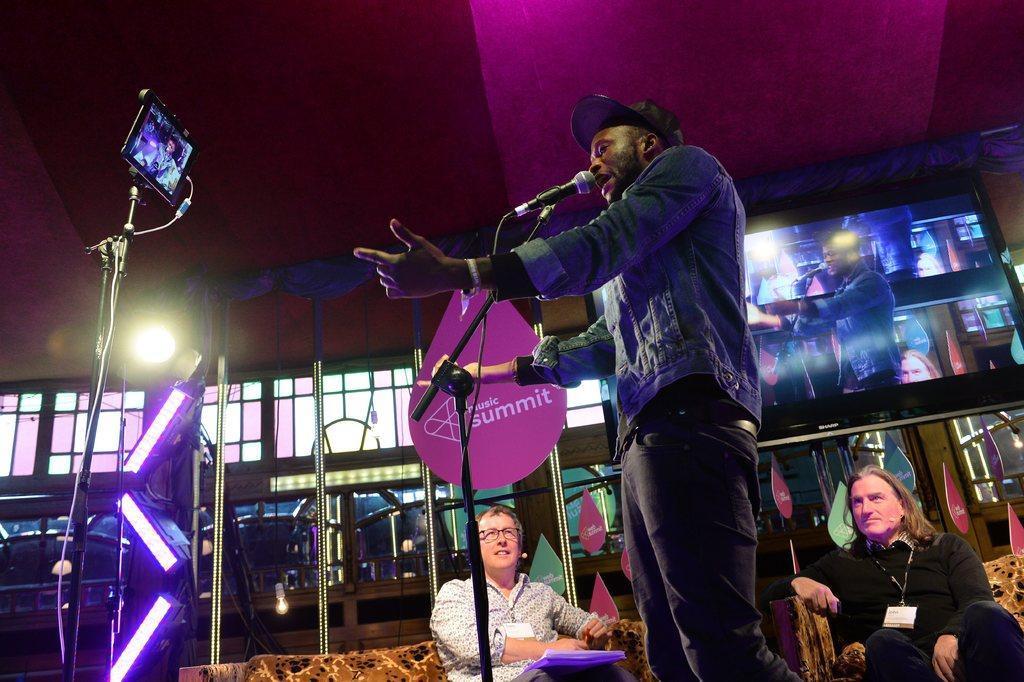Can you describe this image briefly? In this image I can see three persons. Also there is a couch, a mike with stand and an other stand with some object. And there is a screen,lights, glass walls , vehicles and also there are name boards. 